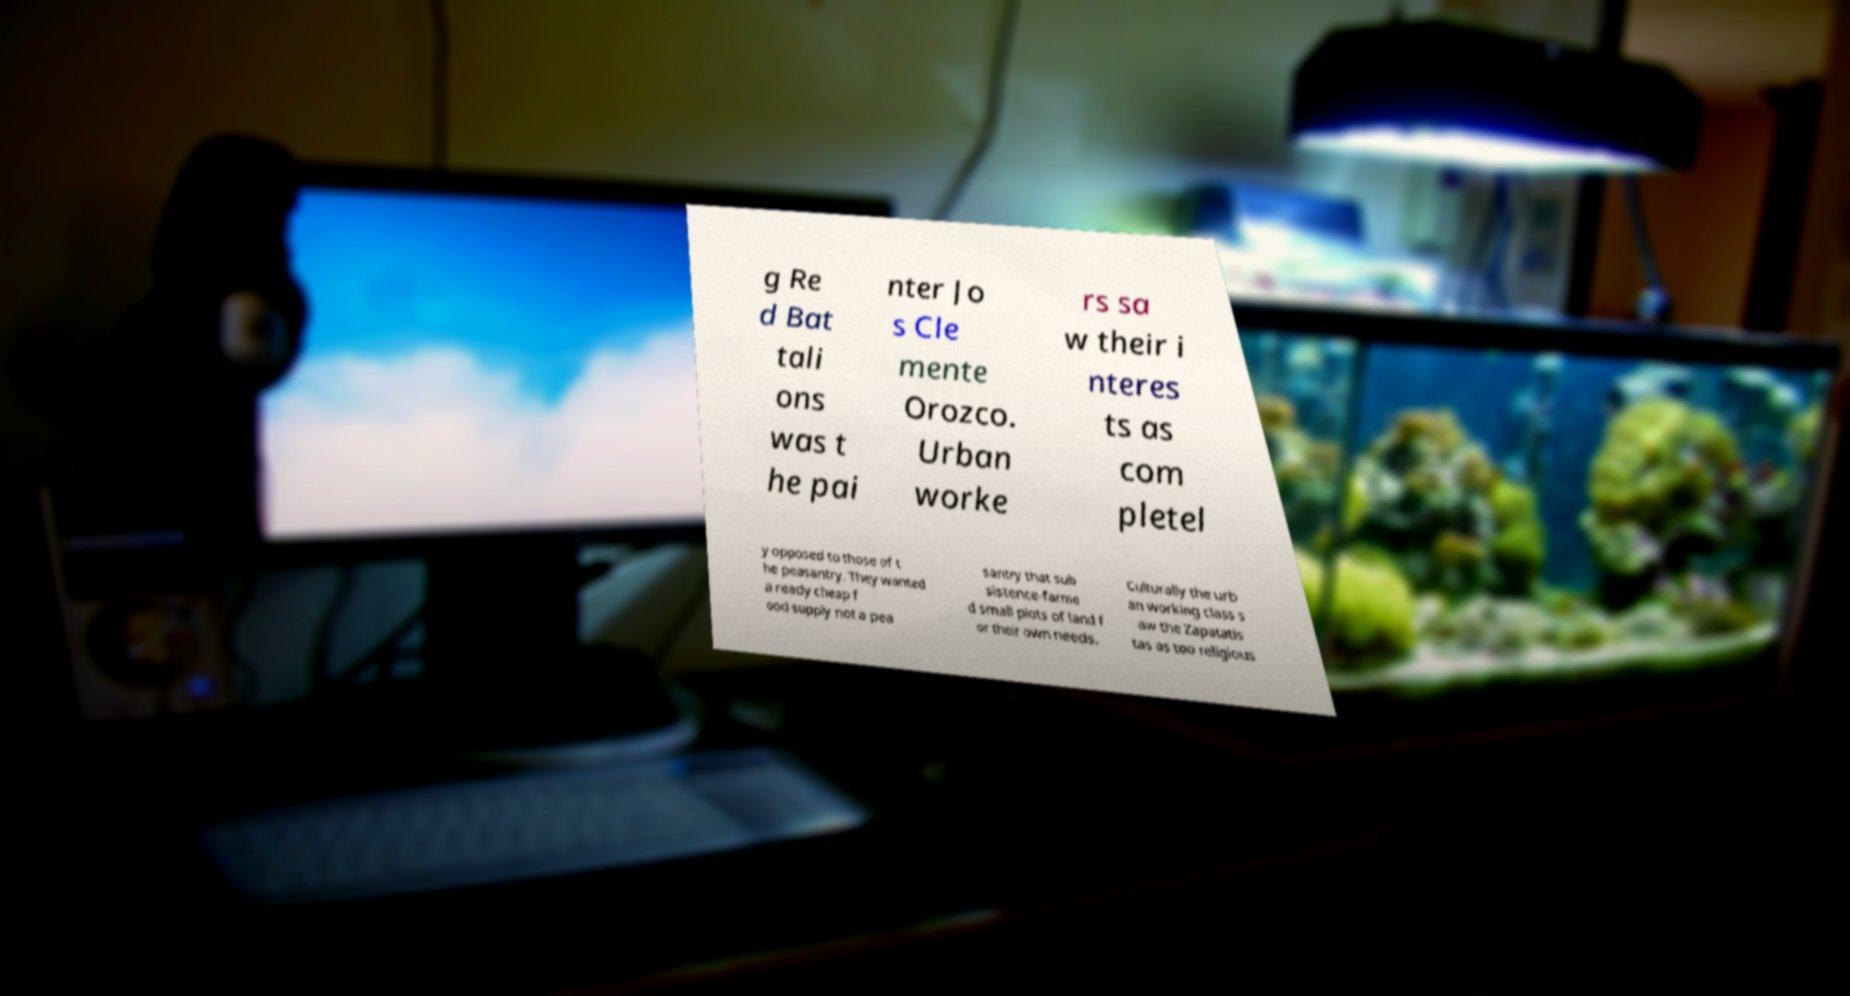Could you assist in decoding the text presented in this image and type it out clearly? g Re d Bat tali ons was t he pai nter Jo s Cle mente Orozco. Urban worke rs sa w their i nteres ts as com pletel y opposed to those of t he peasantry. They wanted a ready cheap f ood supply not a pea santry that sub sistence-farme d small plots of land f or their own needs. Culturally the urb an working class s aw the Zapatatis tas as too religious 